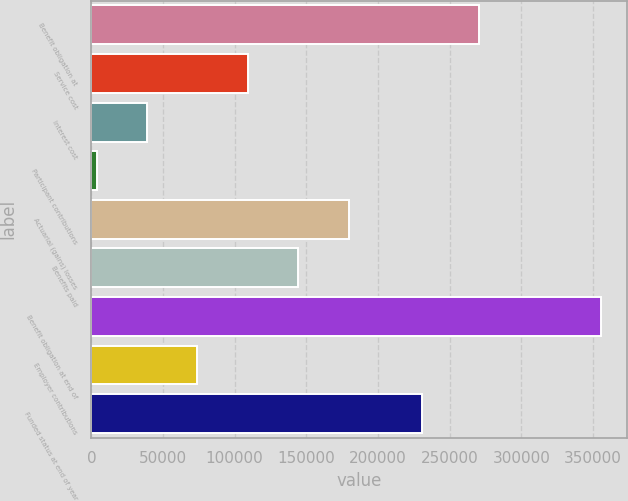Convert chart to OTSL. <chart><loc_0><loc_0><loc_500><loc_500><bar_chart><fcel>Benefit obligation at<fcel>Service cost<fcel>Interest cost<fcel>Participant contributions<fcel>Actuarial (gains) losses<fcel>Benefits paid<fcel>Benefit obligation at end of<fcel>Employer contributions<fcel>Funded status at end of year<nl><fcel>270607<fcel>109276<fcel>38850.8<fcel>3638<fcel>179702<fcel>144489<fcel>355766<fcel>74063.6<fcel>230882<nl></chart> 